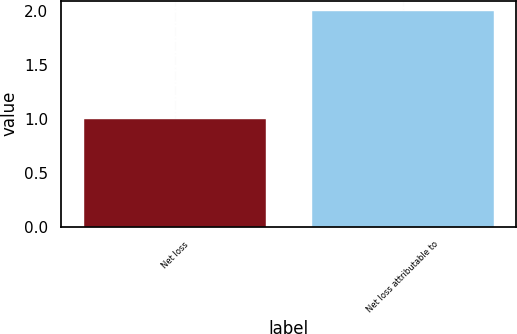<chart> <loc_0><loc_0><loc_500><loc_500><bar_chart><fcel>Net loss<fcel>Net loss attributable to<nl><fcel>1<fcel>2<nl></chart> 